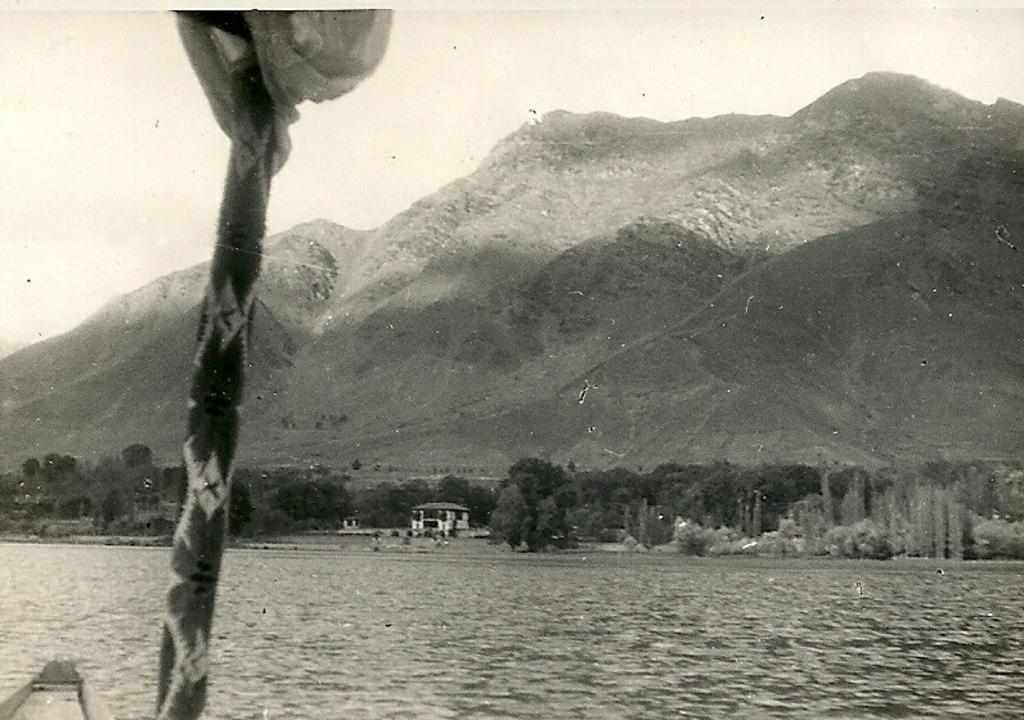Could you give a brief overview of what you see in this image? In this image we can see a boat on the water, there is an object looks like a stick, in the background there are few trees, a building, mountains and the sky. 